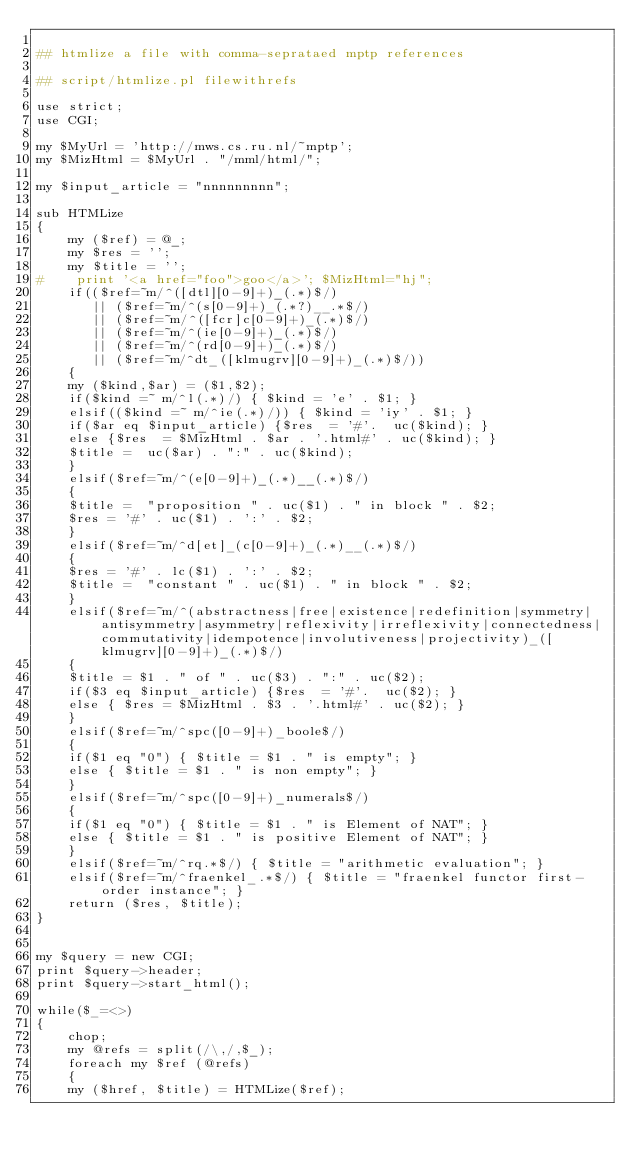Convert code to text. <code><loc_0><loc_0><loc_500><loc_500><_Perl_>
## htmlize a file with comma-seprataed mptp references

## script/htmlize.pl filewithrefs

use strict;
use CGI;

my $MyUrl = 'http://mws.cs.ru.nl/~mptp';
my $MizHtml = $MyUrl . "/mml/html/";

my $input_article = "nnnnnnnnn";

sub HTMLize
{
    my ($ref) = @_;
    my $res = '';
    my $title = '';
#    print '<a href="foo">goo</a>'; $MizHtml="hj";
    if(($ref=~m/^([dtl][0-9]+)_(.*)$/) 
       || ($ref=~m/^(s[0-9]+)_(.*?)__.*$/) 
       || ($ref=~m/^([fcr]c[0-9]+)_(.*)$/) 
       || ($ref=~m/^(ie[0-9]+)_(.*)$/) 
       || ($ref=~m/^(rd[0-9]+)_(.*)$/) 
       || ($ref=~m/^dt_([klmugrv][0-9]+)_(.*)$/))
    {
	my ($kind,$ar) = ($1,$2);
	if($kind =~ m/^l(.*)/) { $kind = 'e' . $1; }
	elsif(($kind =~ m/^ie(.*)/)) { $kind = 'iy' . $1; }
	if($ar eq $input_article) {$res  = '#'.  uc($kind); }
	else {$res  = $MizHtml . $ar . '.html#' . uc($kind); }
	$title =  uc($ar) . ":" . uc($kind);
    }
    elsif($ref=~m/^(e[0-9]+)_(.*)__(.*)$/)
    {
	$title =  "proposition " . uc($1) . " in block " . $2;
	$res = '#' . uc($1) . ':' . $2; 
    }
    elsif($ref=~m/^d[et]_(c[0-9]+)_(.*)__(.*)$/)
    {
	$res = '#' . lc($1) . ':' . $2;
	$title =  "constant " . uc($1) . " in block " . $2;
    }
    elsif($ref=~m/^(abstractness|free|existence|redefinition|symmetry|antisymmetry|asymmetry|reflexivity|irreflexivity|connectedness|commutativity|idempotence|involutiveness|projectivity)_([klmugrv][0-9]+)_(.*)$/)
    {
	$title = $1 . " of " . uc($3) . ":" . uc($2);
	if($3 eq $input_article) {$res  = '#'.  uc($2); }
	else { $res = $MizHtml . $3 . '.html#' . uc($2); }
    }
    elsif($ref=~m/^spc([0-9]+)_boole$/) 
    {
	if($1 eq "0") { $title = $1 . " is empty"; } 
	else { $title = $1 . " is non empty"; } 
    }
    elsif($ref=~m/^spc([0-9]+)_numerals$/)
    {
	if($1 eq "0") { $title = $1 . " is Element of NAT"; }
	else { $title = $1 . " is positive Element of NAT"; }
    }
    elsif($ref=~m/^rq.*$/) { $title = "arithmetic evaluation"; }
    elsif($ref=~m/^fraenkel_.*$/) { $title = "fraenkel functor first-order instance"; }
    return ($res, $title);
}


my $query = new CGI;
print $query->header;
print $query->start_html();

while($_=<>)
{
    chop;
    my @refs = split(/\,/,$_);
    foreach my $ref (@refs)
    {
	my ($href, $title) = HTMLize($ref);</code> 